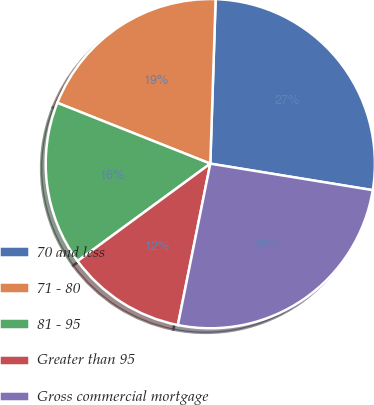<chart> <loc_0><loc_0><loc_500><loc_500><pie_chart><fcel>70 and less<fcel>71 - 80<fcel>81 - 95<fcel>Greater than 95<fcel>Gross commercial mortgage<nl><fcel>27.06%<fcel>19.49%<fcel>16.1%<fcel>11.77%<fcel>25.58%<nl></chart> 